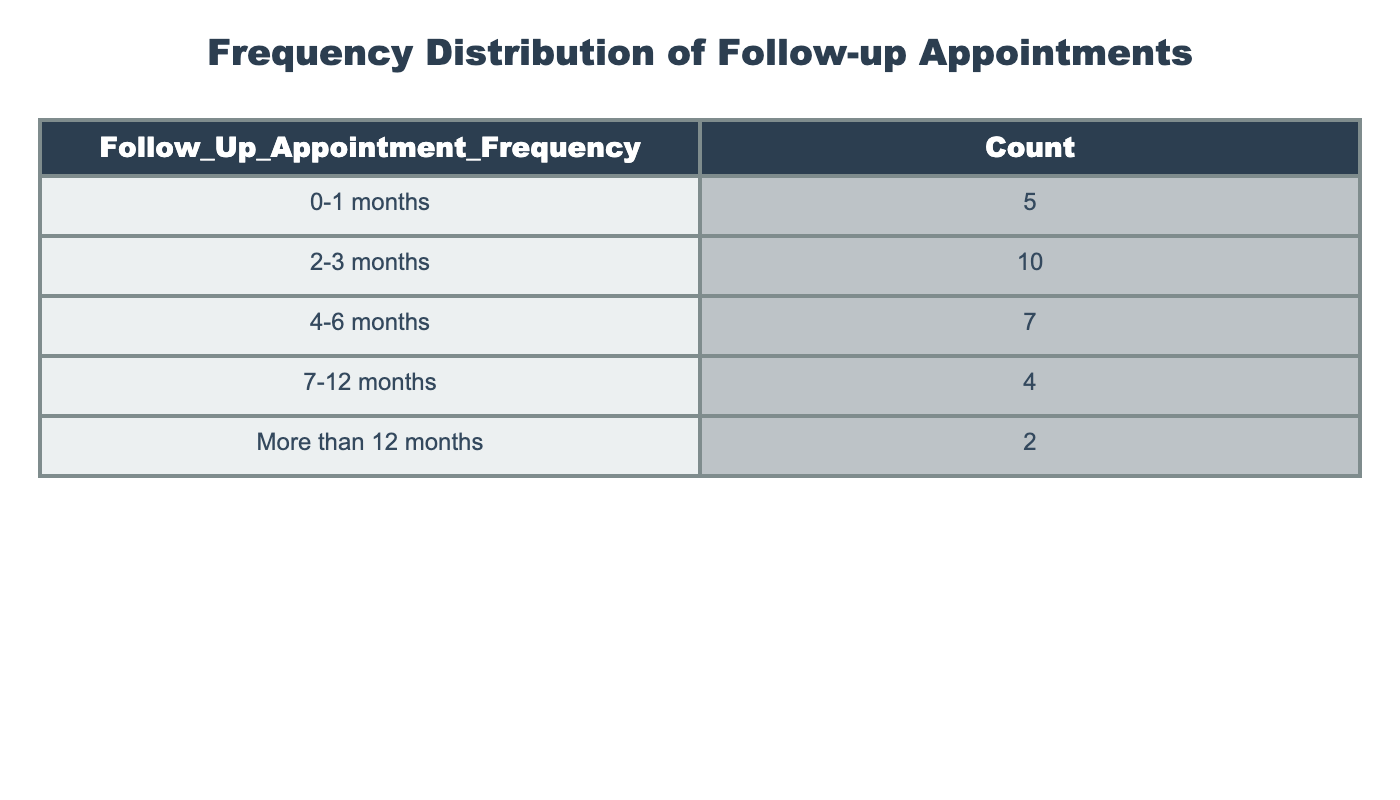What is the count of follow-up appointments scheduled within 0-1 months? According to the table, under the category "0-1 months," the count is explicitly listed as 5.
Answer: 5 What is the category with the highest number of follow-up appointments? By examining the counts for each category, "2-3 months" has the highest count of 10.
Answer: 2-3 months How many follow-up appointments were scheduled in total within 4-6 months and 7-12 months? For "4-6 months," the count is 7 and for "7-12 months," the count is 4. Adding these gives a total of 7 + 4 = 11.
Answer: 11 Does the count of follow-up appointments scheduled for "More than 12 months" exceed the count for "7-12 months"? The count for "More than 12 months" is 2, while for "7-12 months" it is 4. Since 2 is less than 4, the answer is no.
Answer: No What percentage of follow-up appointments are scheduled within 2-3 months? There are a total of 38 appointments (5 + 10 + 7 + 4 + 2). The count for "2-3 months" is 10. The percentage is (10/38) * 100, which is approximately 26.32%.
Answer: 26.32% What is the combined count of appointments scheduled for categories "0-1 months" and "More than 12 months"? The count for "0-1 months" is 5 and for "More than 12 months" it is 2. Combining these gives 5 + 2 = 7.
Answer: 7 Are there more follow-up appointments scheduled in the category "4-6 months" than in "0-1 months"? The count for "4-6 months" is 7 while for "0-1 months" it is 5. Since 7 is greater than 5, the answer is yes.
Answer: Yes What is the average number of follow-up appointments scheduled across all categories? Adding the counts gives a total of 38 (5 + 10 + 7 + 4 + 2). There are 5 categories, so the average is 38 / 5 = 7.6.
Answer: 7.6 What is the difference in follow-up appointment counts between the categories "2-3 months" and "7-12 months"? "2-3 months" has a count of 10 and "7-12 months" has a count of 4. The difference is 10 - 4 = 6.
Answer: 6 